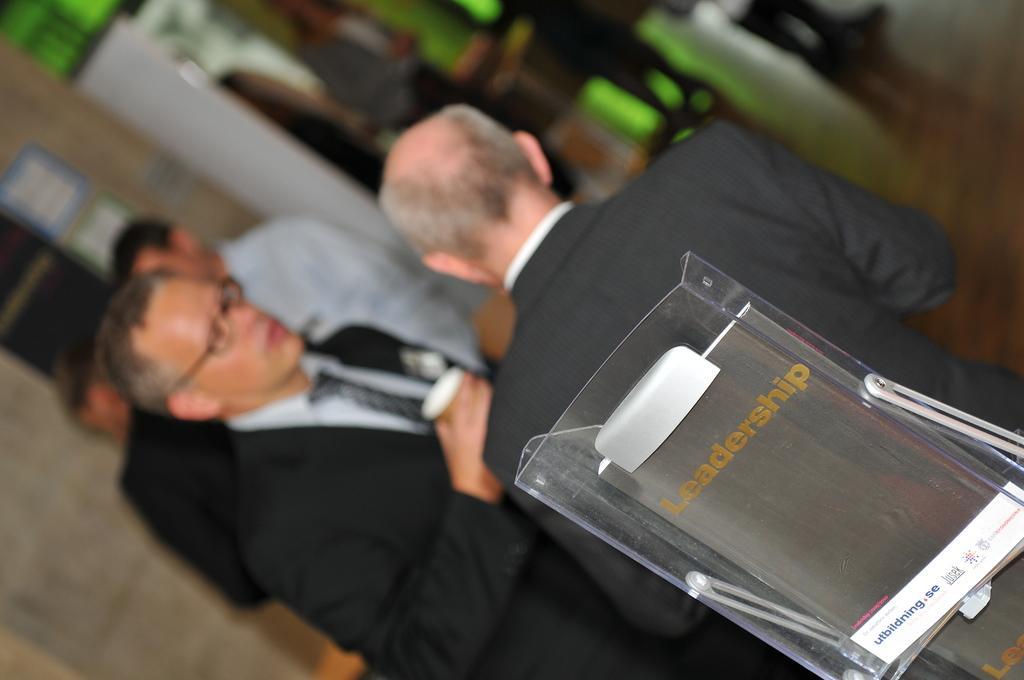In one or two sentences, can you explain what this image depicts? In this image I can see the books on the glass stand. In the background I can see the group of people standing and boards to the wall. I can see the background is blurred. 